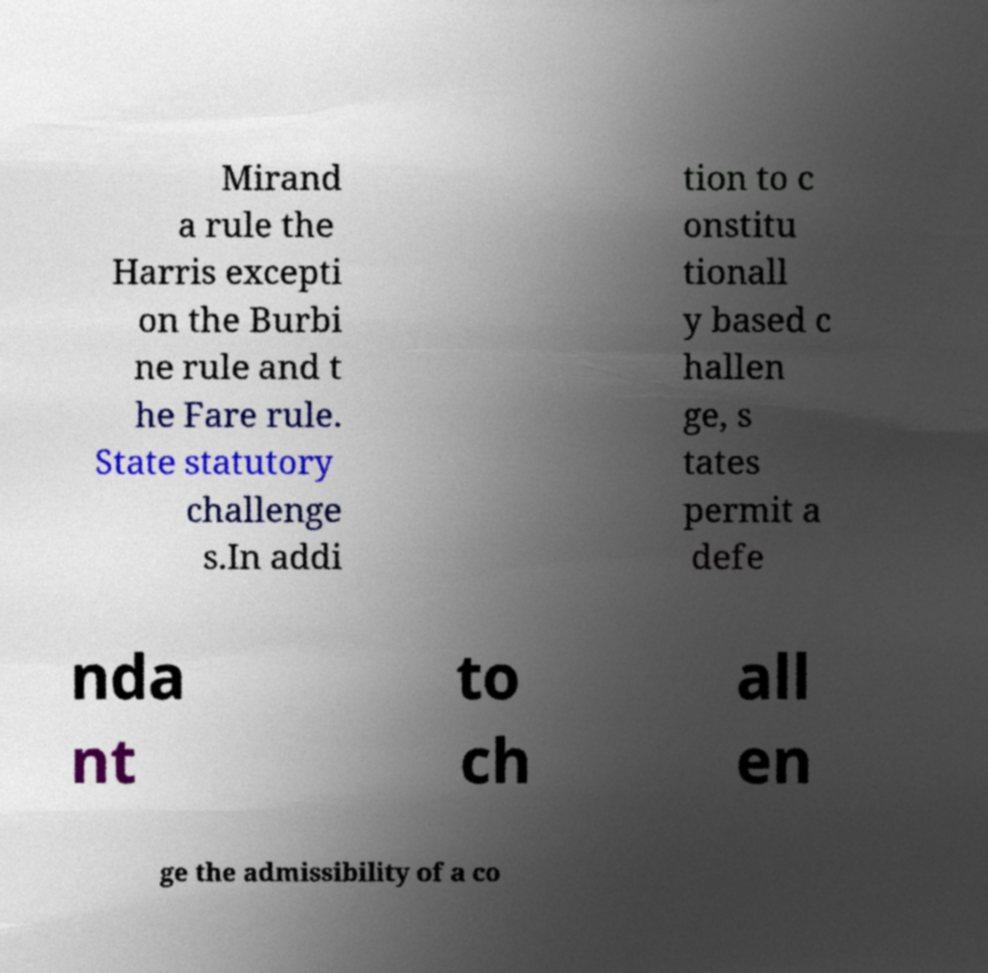There's text embedded in this image that I need extracted. Can you transcribe it verbatim? Mirand a rule the Harris excepti on the Burbi ne rule and t he Fare rule. State statutory challenge s.In addi tion to c onstitu tionall y based c hallen ge, s tates permit a defe nda nt to ch all en ge the admissibility of a co 